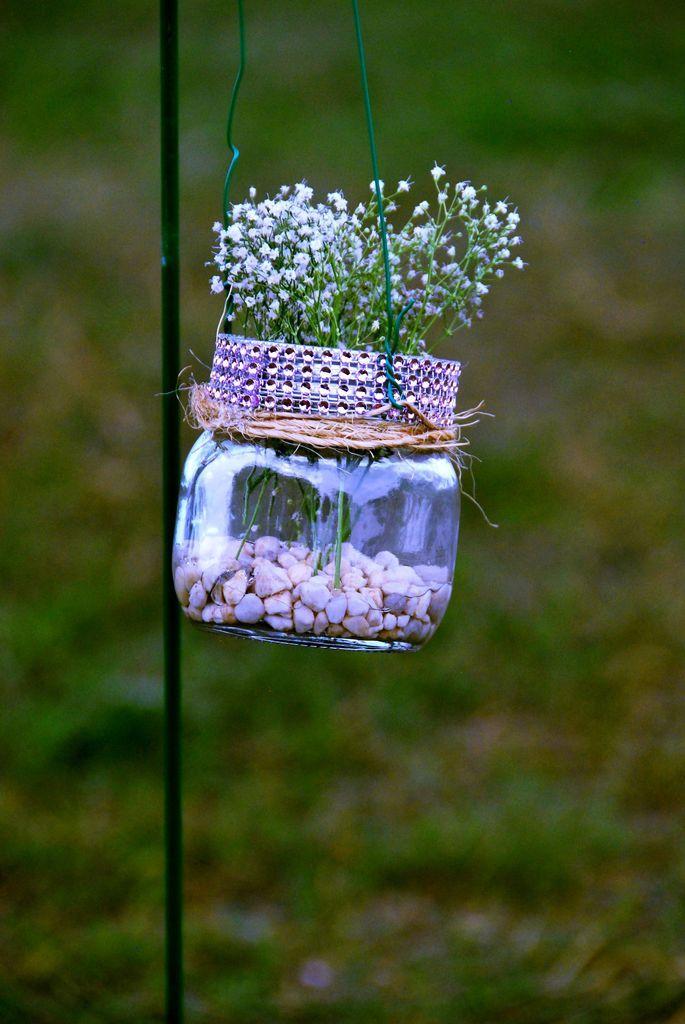Could you give a brief overview of what you see in this image? In the image we can see glass jar, in it there are stones and tiny flowers. Here we can see greenish background. 